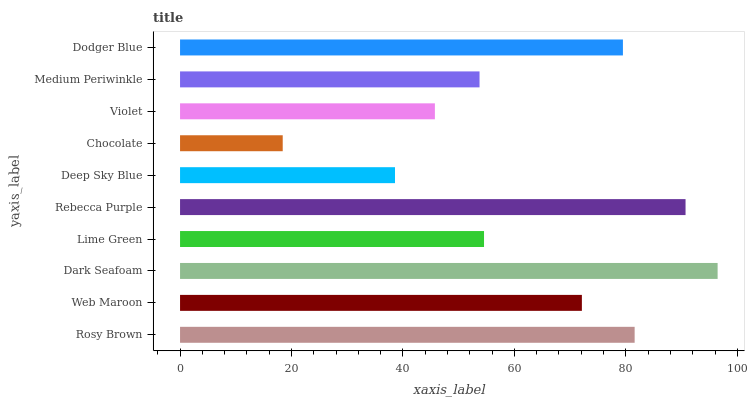Is Chocolate the minimum?
Answer yes or no. Yes. Is Dark Seafoam the maximum?
Answer yes or no. Yes. Is Web Maroon the minimum?
Answer yes or no. No. Is Web Maroon the maximum?
Answer yes or no. No. Is Rosy Brown greater than Web Maroon?
Answer yes or no. Yes. Is Web Maroon less than Rosy Brown?
Answer yes or no. Yes. Is Web Maroon greater than Rosy Brown?
Answer yes or no. No. Is Rosy Brown less than Web Maroon?
Answer yes or no. No. Is Web Maroon the high median?
Answer yes or no. Yes. Is Lime Green the low median?
Answer yes or no. Yes. Is Violet the high median?
Answer yes or no. No. Is Rosy Brown the low median?
Answer yes or no. No. 